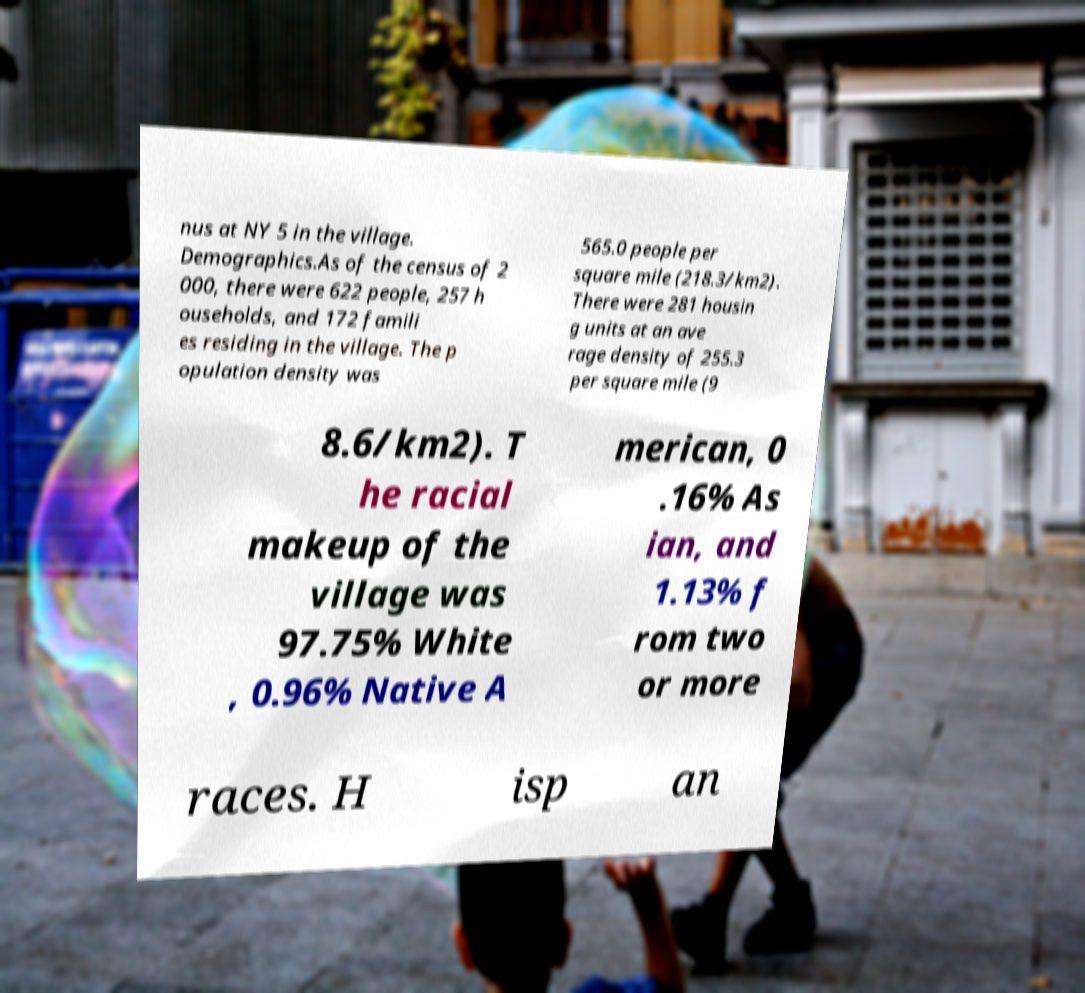What messages or text are displayed in this image? I need them in a readable, typed format. nus at NY 5 in the village. Demographics.As of the census of 2 000, there were 622 people, 257 h ouseholds, and 172 famili es residing in the village. The p opulation density was 565.0 people per square mile (218.3/km2). There were 281 housin g units at an ave rage density of 255.3 per square mile (9 8.6/km2). T he racial makeup of the village was 97.75% White , 0.96% Native A merican, 0 .16% As ian, and 1.13% f rom two or more races. H isp an 